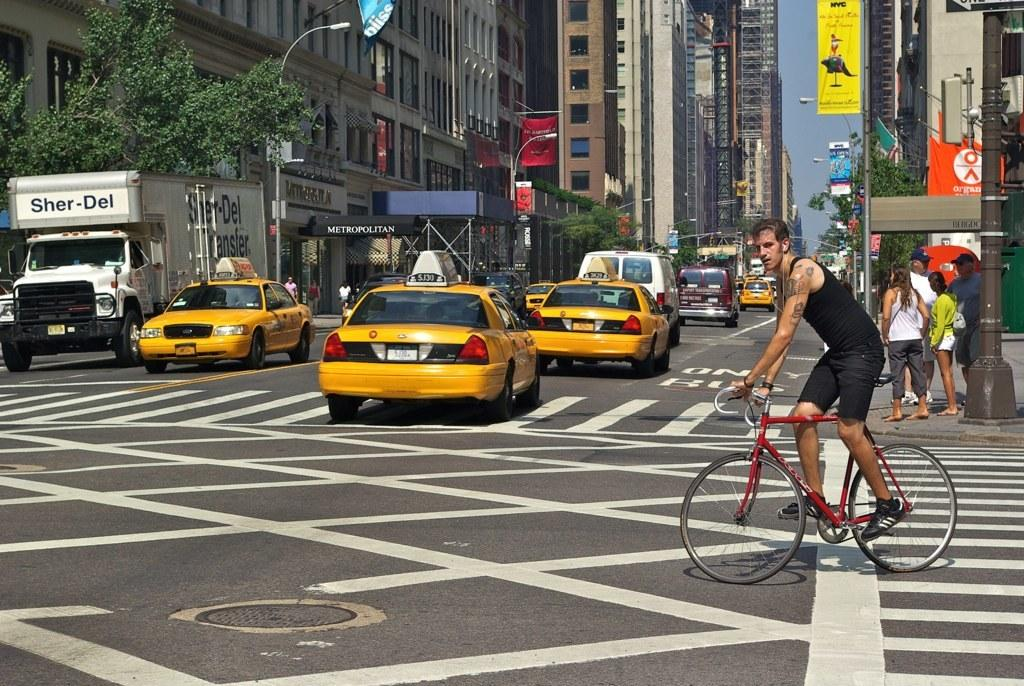<image>
Render a clear and concise summary of the photo. A busy street with a white truck that says Sher-Del on it. 